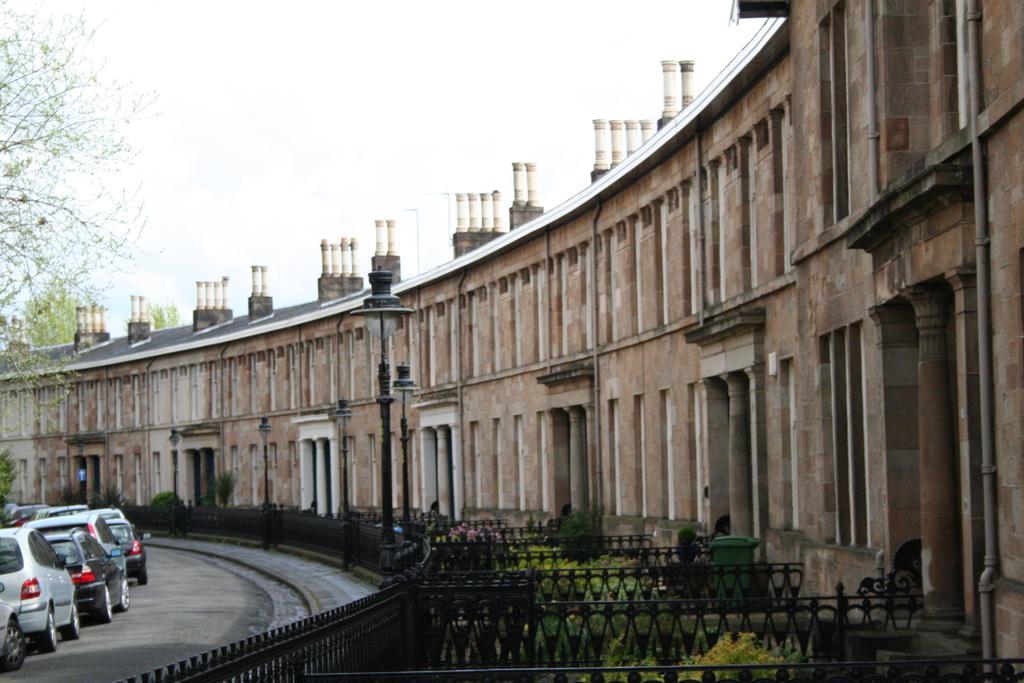Describe this image in one or two sentences. In this image there are buildings, light poles, railing, plants, grilles, vehicles, trees and sky. 